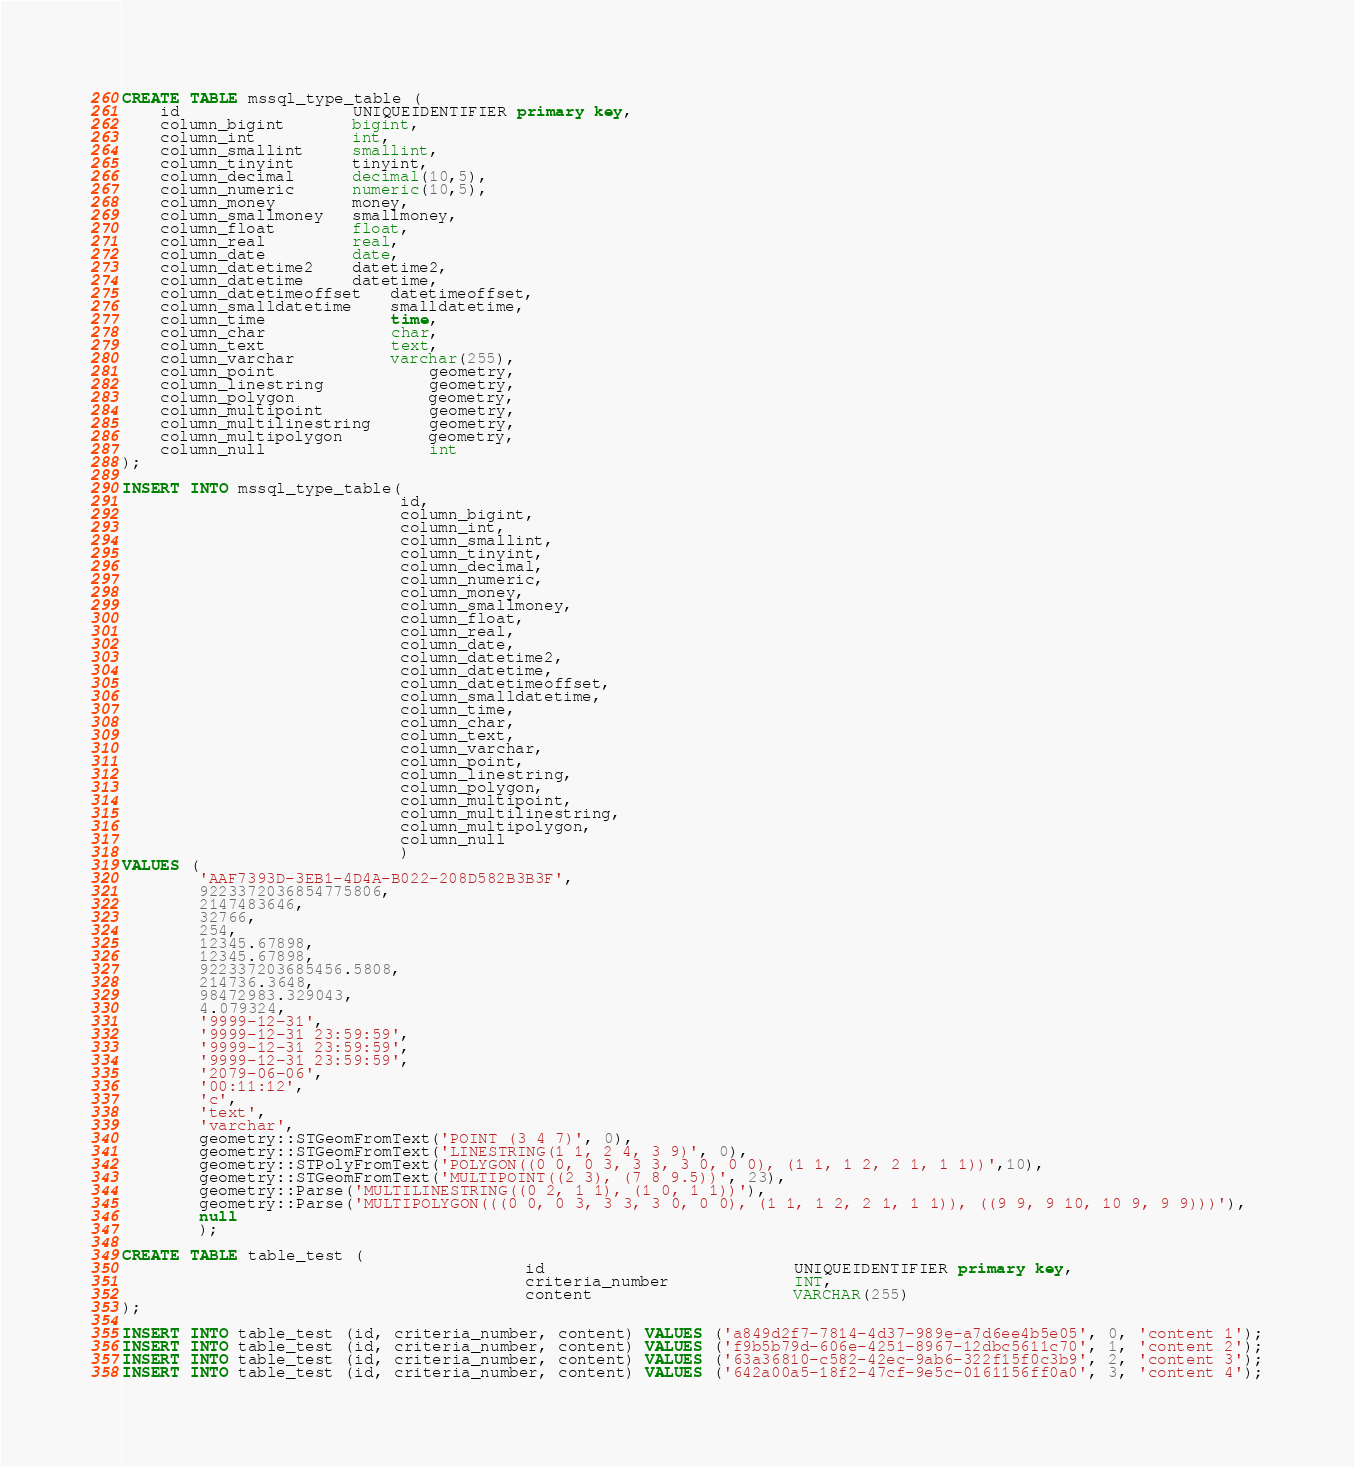<code> <loc_0><loc_0><loc_500><loc_500><_SQL_>CREATE TABLE mssql_type_table (
    id                  UNIQUEIDENTIFIER primary key,
    column_bigint       bigint,
    column_int          int,
    column_smallint     smallint,
    column_tinyint      tinyint,
    column_decimal      decimal(10,5),
    column_numeric      numeric(10,5),
    column_money        money,
    column_smallmoney   smallmoney,
    column_float        float,
    column_real         real,
    column_date         date,
    column_datetime2    datetime2,
    column_datetime     datetime,
    column_datetimeoffset   datetimeoffset,
    column_smalldatetime    smalldatetime,
    column_time             time,
    column_char             char,
    column_text             text,
    column_varchar          varchar(255),
    column_point                geometry,
    column_linestring           geometry,
    column_polygon              geometry,
    column_multipoint           geometry,
    column_multilinestring      geometry,
    column_multipolygon         geometry,
    column_null                 int
);

INSERT INTO mssql_type_table(
                             id,
                             column_bigint,
                             column_int,
                             column_smallint,
                             column_tinyint,
                             column_decimal,
                             column_numeric,
                             column_money,
                             column_smallmoney,
                             column_float,
                             column_real,
                             column_date,
                             column_datetime2,
                             column_datetime,
                             column_datetimeoffset,
                             column_smalldatetime,
                             column_time,
                             column_char,
                             column_text,
                             column_varchar,
                             column_point,
                             column_linestring,
                             column_polygon,
                             column_multipoint,
                             column_multilinestring,
                             column_multipolygon,
                             column_null
                             )
VALUES (
        'AAF7393D-3EB1-4D4A-B022-208D582B3B3F',
        9223372036854775806,
        2147483646,
        32766,
        254,
        12345.67898,
        12345.67898,
        922337203685456.5808,
        214736.3648,
        98472983.329043,
        4.079324,
        '9999-12-31',
        '9999-12-31 23:59:59',
        '9999-12-31 23:59:59',
        '9999-12-31 23:59:59',
        '2079-06-06',
        '00:11:12',
        'c',
        'text',
        'varchar',
        geometry::STGeomFromText('POINT (3 4 7)', 0),
        geometry::STGeomFromText('LINESTRING(1 1, 2 4, 3 9)', 0),
        geometry::STPolyFromText('POLYGON((0 0, 0 3, 3 3, 3 0, 0 0), (1 1, 1 2, 2 1, 1 1))',10),
        geometry::STGeomFromText('MULTIPOINT((2 3), (7 8 9.5))', 23),
        geometry::Parse('MULTILINESTRING((0 2, 1 1), (1 0, 1 1))'),
        geometry::Parse('MULTIPOLYGON(((0 0, 0 3, 3 3, 3 0, 0 0), (1 1, 1 2, 2 1, 1 1)), ((9 9, 9 10, 10 9, 9 9)))'),
        null
        );

CREATE TABLE table_test (
                                          id                          UNIQUEIDENTIFIER primary key,
                                          criteria_number             INT,
                                          content                     VARCHAR(255)
);

INSERT INTO table_test (id, criteria_number, content) VALUES ('a849d2f7-7814-4d37-989e-a7d6ee4b5e05', 0, 'content 1');
INSERT INTO table_test (id, criteria_number, content) VALUES ('f9b5b79d-606e-4251-8967-12dbc5611c70', 1, 'content 2');
INSERT INTO table_test (id, criteria_number, content) VALUES ('63a36810-c582-42ec-9ab6-322f15f0c3b9', 2, 'content 3');
INSERT INTO table_test (id, criteria_number, content) VALUES ('642a00a5-18f2-47cf-9e5c-0161156ff0a0', 3, 'content 4');</code> 